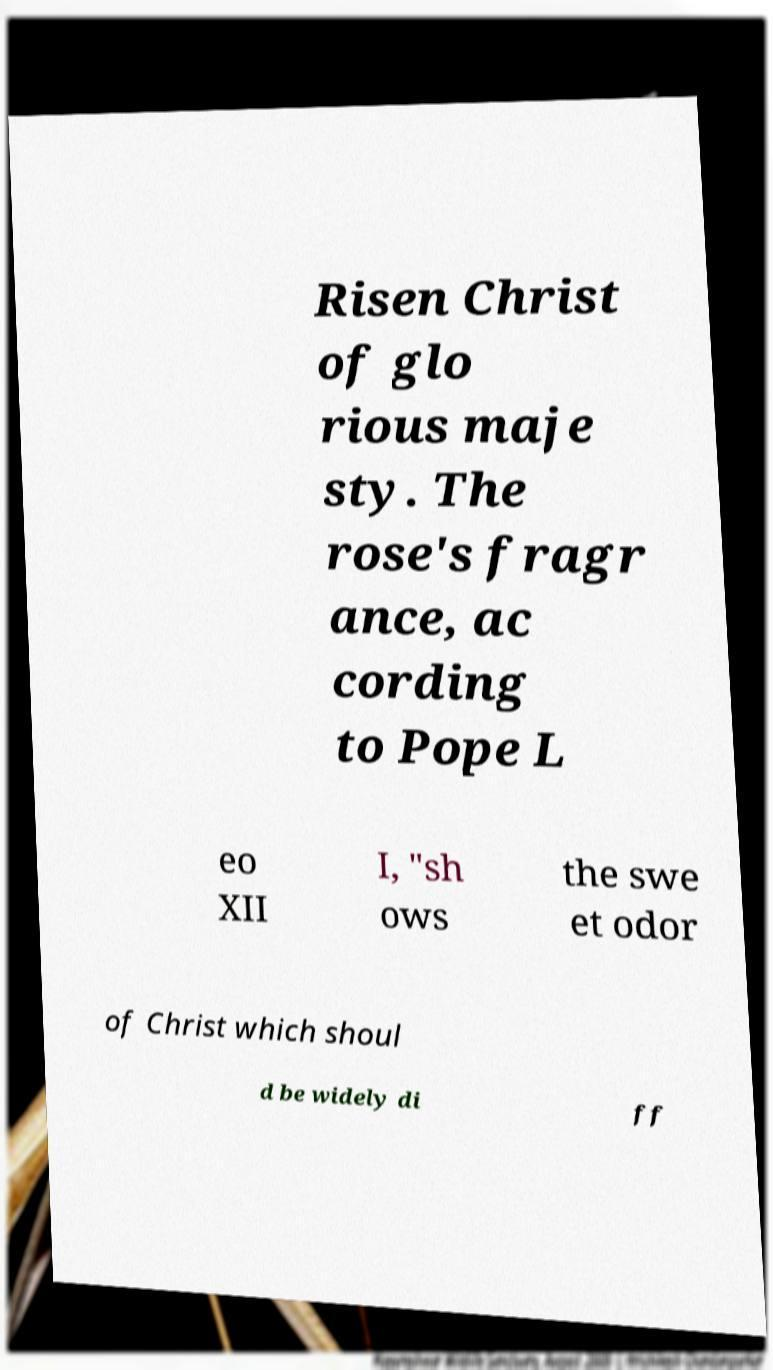Please identify and transcribe the text found in this image. Risen Christ of glo rious maje sty. The rose's fragr ance, ac cording to Pope L eo XII I, "sh ows the swe et odor of Christ which shoul d be widely di ff 